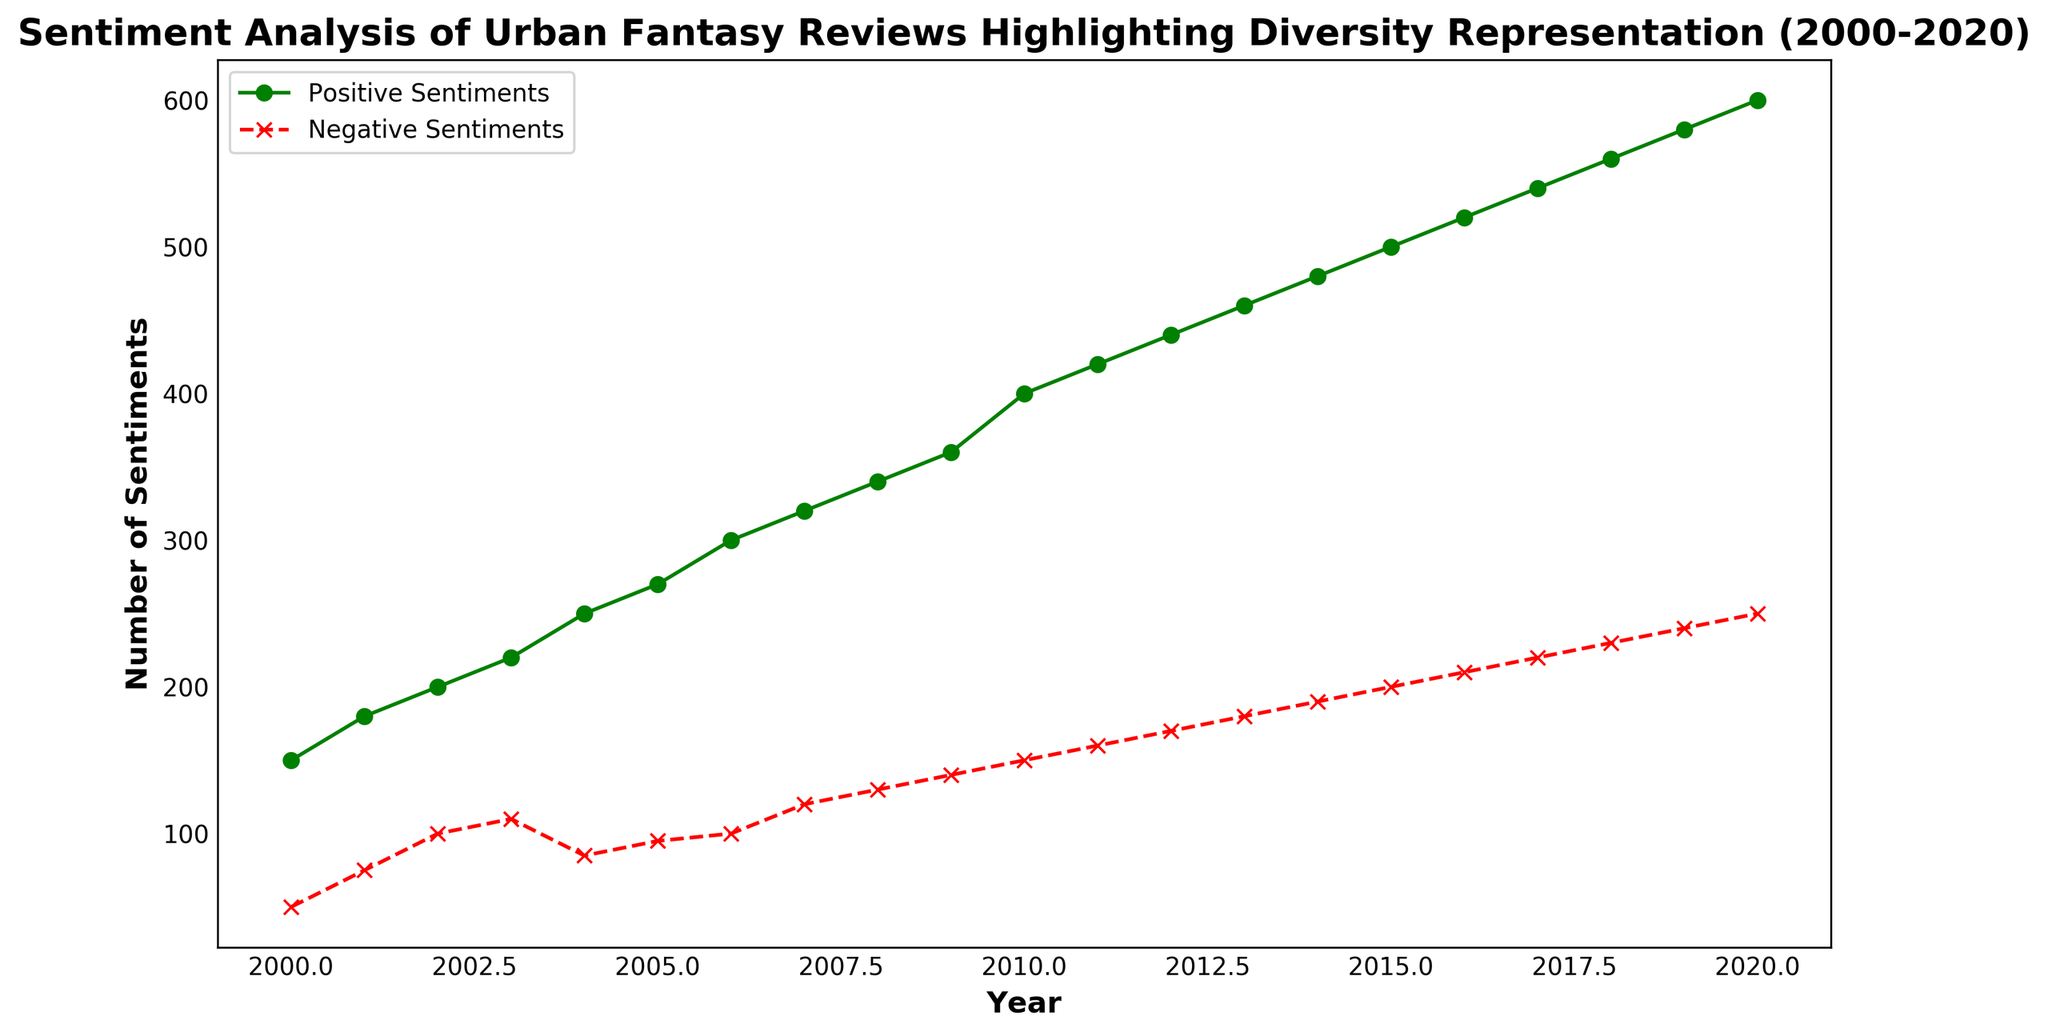What was the total number of positive sentiments from 2010 to 2020? Adding the values for positive sentiments from 2010 to 2020: 400 + 420 + 440 + 460 + 480 + 500 + 520 + 540 + 560 + 580 + 600 = 5500
Answer: 5500 What year did negative sentiments first reach 200? Looking at the negative sentiments plot, the value reaches 200 in the year 2015
Answer: 2015 In which year was the disparity between positive and negative sentiments the smallest? Calculate the difference between positive and negative sentiments for each year and find the smallest value: 150-50=100, 180-75=105, 200-100=100, 220-110=110, 250-85=165, 270-95=175, 300-100=200, 320-120=200, 340-130=210, 360-140=220, 400-150=250, 420-160=260, 440-170=270, 460-180=280, 480-190=290, 500-200=300, 520-210=310, 540-220=320, 560-230=330, 580-240=340, 600-250=350. The smallest disparity occurs in the years 2000 and 2002 with a disparity of 100
Answer: 2000, 2002 By what percentage did positive sentiments increase from 2000 to 2020? Calculate the percentage increase: ((600 - 150) / 150) * 100 = 300%
Answer: 300% What trend do you observe in positive and negative sentiments over the 20-year period? Positive sentiments exhibit a consistently upward trend, starting at 150 in 2000 and reaching 600 in 2020. Negative sentiments also show an upward trend, increasing from 50 in 2000 to 250 in 2020
Answer: Upward trend for both How much higher were the positive sentiments compared to negative sentiments in 2018? Positive sentiments in 2018 were 560, and negative sentiments were 230. The difference is 560 - 230 = 330
Answer: 330 What is the average number of negative sentiments per year from 2000 to 2020? Sum the negative sentiments from 2000 to 2020 and divide by the number of years (21): (50 + 75 + 100 + 110 + 85 + 95 + 100 + 120 + 130 + 140 + 150 + 160 + 170 + 180 + 190 + 200 + 210 + 220 + 230 + 240 + 250) / 21 ≈ 146.19
Answer: 146.19 Between which consecutive years did positive sentiments increase the most? Calculate the year-over-year increase for positive sentiments and find the largest: 180-150=30, 200-180=20, 220-200=20, 250-220=30, 270-250=20, 300-270=30, 320-300=20, 340-320=20, 360-340=20, 400-360=40, 420-400=20, 440-420=20, 460-440=20, 480-460=20, 500-480=20, 520-500=20, 540-520=20, 560-540=20, 580-560=20, 600-580=20. The largest increase happened between 2009 and 2010
Answer: 2009 and 2010 In which year did positive sentiments exceed 500? Positive sentiments exceeded 500 for the first time in the year 2015
Answer: 2015 Which year shows the least difference between positive and negative sentiments? Calculate the differences and compare: (150-50) = 100, (180-75) = 105, (200-100) = 100, (220-110) = 110, (250-85) = 165, (270-95) = 175, (300-100) = 200, (320-120) = 200, (340-130) = 210, (360-140) = 220, (400-150) = 250, (420-160) = 260, (440-170) = 270, (460-180) = 280, (480-190) = 290, (500-200) = 300, (520-210) = 310, (540-220) = 320, (560-230) = 330, (580-240) = 340, (600-250) = 350. The years 2000 and 2002 have the smallest differences of 100
Answer: 2000, 2002 